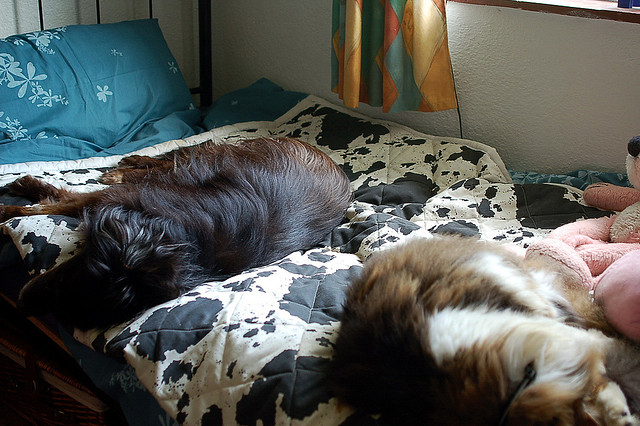How many dogs are in the photo? There are two dogs in the photo. Both appear to be enjoying a peaceful nap on a comfortable bed with a cow-patterned duvet, which adds a homey and relaxed feel to the scene. 